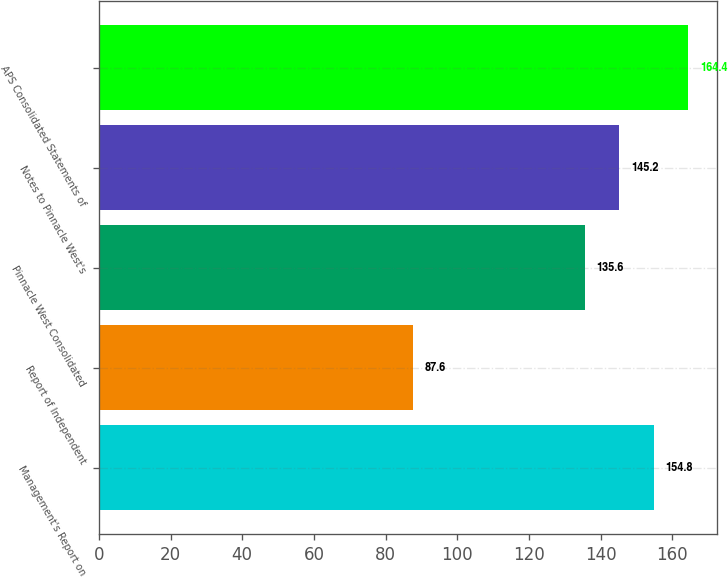<chart> <loc_0><loc_0><loc_500><loc_500><bar_chart><fcel>Management's Report on<fcel>Report of Independent<fcel>Pinnacle West Consolidated<fcel>Notes to Pinnacle West's<fcel>APS Consolidated Statements of<nl><fcel>154.8<fcel>87.6<fcel>135.6<fcel>145.2<fcel>164.4<nl></chart> 